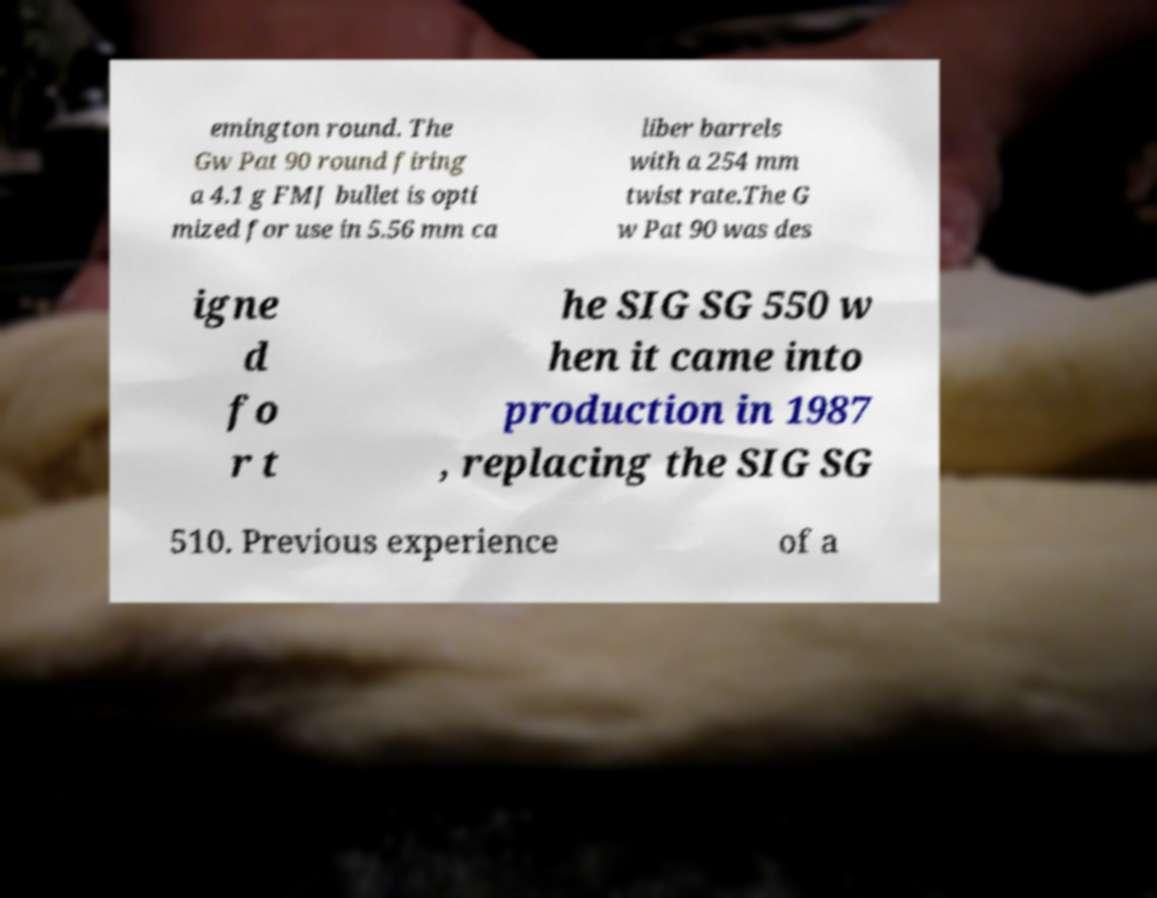There's text embedded in this image that I need extracted. Can you transcribe it verbatim? emington round. The Gw Pat 90 round firing a 4.1 g FMJ bullet is opti mized for use in 5.56 mm ca liber barrels with a 254 mm twist rate.The G w Pat 90 was des igne d fo r t he SIG SG 550 w hen it came into production in 1987 , replacing the SIG SG 510. Previous experience of a 